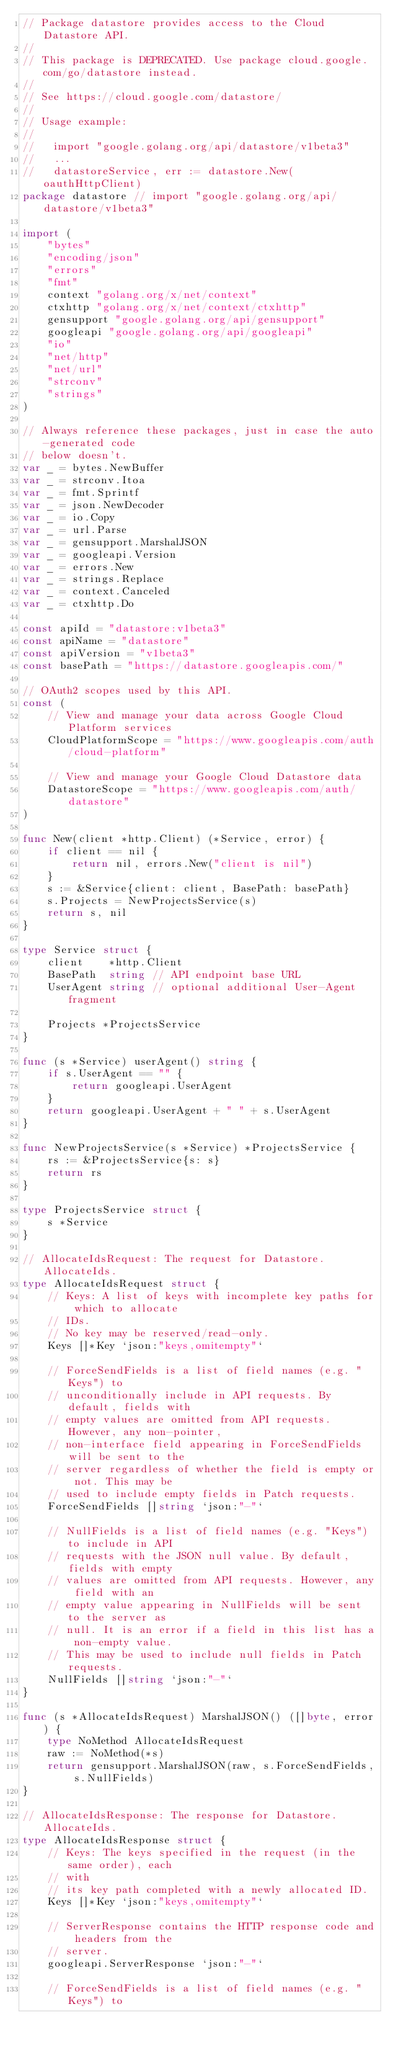<code> <loc_0><loc_0><loc_500><loc_500><_Go_>// Package datastore provides access to the Cloud Datastore API.
//
// This package is DEPRECATED. Use package cloud.google.com/go/datastore instead.
//
// See https://cloud.google.com/datastore/
//
// Usage example:
//
//   import "google.golang.org/api/datastore/v1beta3"
//   ...
//   datastoreService, err := datastore.New(oauthHttpClient)
package datastore // import "google.golang.org/api/datastore/v1beta3"

import (
	"bytes"
	"encoding/json"
	"errors"
	"fmt"
	context "golang.org/x/net/context"
	ctxhttp "golang.org/x/net/context/ctxhttp"
	gensupport "google.golang.org/api/gensupport"
	googleapi "google.golang.org/api/googleapi"
	"io"
	"net/http"
	"net/url"
	"strconv"
	"strings"
)

// Always reference these packages, just in case the auto-generated code
// below doesn't.
var _ = bytes.NewBuffer
var _ = strconv.Itoa
var _ = fmt.Sprintf
var _ = json.NewDecoder
var _ = io.Copy
var _ = url.Parse
var _ = gensupport.MarshalJSON
var _ = googleapi.Version
var _ = errors.New
var _ = strings.Replace
var _ = context.Canceled
var _ = ctxhttp.Do

const apiId = "datastore:v1beta3"
const apiName = "datastore"
const apiVersion = "v1beta3"
const basePath = "https://datastore.googleapis.com/"

// OAuth2 scopes used by this API.
const (
	// View and manage your data across Google Cloud Platform services
	CloudPlatformScope = "https://www.googleapis.com/auth/cloud-platform"

	// View and manage your Google Cloud Datastore data
	DatastoreScope = "https://www.googleapis.com/auth/datastore"
)

func New(client *http.Client) (*Service, error) {
	if client == nil {
		return nil, errors.New("client is nil")
	}
	s := &Service{client: client, BasePath: basePath}
	s.Projects = NewProjectsService(s)
	return s, nil
}

type Service struct {
	client    *http.Client
	BasePath  string // API endpoint base URL
	UserAgent string // optional additional User-Agent fragment

	Projects *ProjectsService
}

func (s *Service) userAgent() string {
	if s.UserAgent == "" {
		return googleapi.UserAgent
	}
	return googleapi.UserAgent + " " + s.UserAgent
}

func NewProjectsService(s *Service) *ProjectsService {
	rs := &ProjectsService{s: s}
	return rs
}

type ProjectsService struct {
	s *Service
}

// AllocateIdsRequest: The request for Datastore.AllocateIds.
type AllocateIdsRequest struct {
	// Keys: A list of keys with incomplete key paths for which to allocate
	// IDs.
	// No key may be reserved/read-only.
	Keys []*Key `json:"keys,omitempty"`

	// ForceSendFields is a list of field names (e.g. "Keys") to
	// unconditionally include in API requests. By default, fields with
	// empty values are omitted from API requests. However, any non-pointer,
	// non-interface field appearing in ForceSendFields will be sent to the
	// server regardless of whether the field is empty or not. This may be
	// used to include empty fields in Patch requests.
	ForceSendFields []string `json:"-"`

	// NullFields is a list of field names (e.g. "Keys") to include in API
	// requests with the JSON null value. By default, fields with empty
	// values are omitted from API requests. However, any field with an
	// empty value appearing in NullFields will be sent to the server as
	// null. It is an error if a field in this list has a non-empty value.
	// This may be used to include null fields in Patch requests.
	NullFields []string `json:"-"`
}

func (s *AllocateIdsRequest) MarshalJSON() ([]byte, error) {
	type NoMethod AllocateIdsRequest
	raw := NoMethod(*s)
	return gensupport.MarshalJSON(raw, s.ForceSendFields, s.NullFields)
}

// AllocateIdsResponse: The response for Datastore.AllocateIds.
type AllocateIdsResponse struct {
	// Keys: The keys specified in the request (in the same order), each
	// with
	// its key path completed with a newly allocated ID.
	Keys []*Key `json:"keys,omitempty"`

	// ServerResponse contains the HTTP response code and headers from the
	// server.
	googleapi.ServerResponse `json:"-"`

	// ForceSendFields is a list of field names (e.g. "Keys") to</code> 